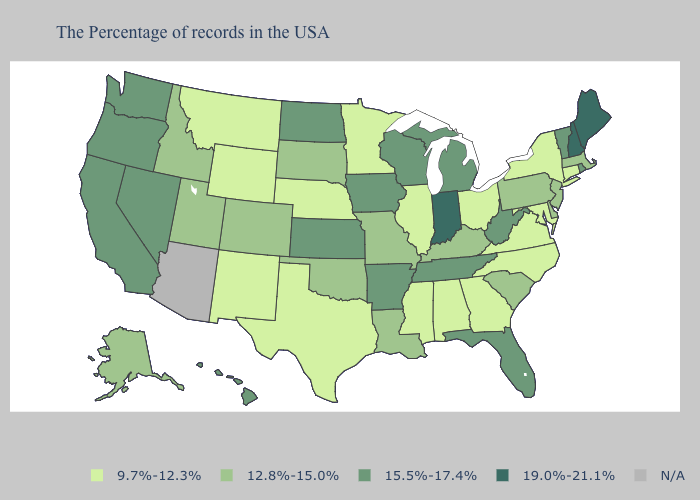Name the states that have a value in the range 9.7%-12.3%?
Quick response, please. Connecticut, New York, Maryland, Virginia, North Carolina, Ohio, Georgia, Alabama, Illinois, Mississippi, Minnesota, Nebraska, Texas, Wyoming, New Mexico, Montana. Does Illinois have the lowest value in the USA?
Keep it brief. Yes. Does the map have missing data?
Quick response, please. Yes. What is the highest value in the USA?
Give a very brief answer. 19.0%-21.1%. Which states have the lowest value in the USA?
Concise answer only. Connecticut, New York, Maryland, Virginia, North Carolina, Ohio, Georgia, Alabama, Illinois, Mississippi, Minnesota, Nebraska, Texas, Wyoming, New Mexico, Montana. What is the value of South Dakota?
Quick response, please. 12.8%-15.0%. Does Oregon have the highest value in the West?
Quick response, please. Yes. Which states have the lowest value in the MidWest?
Write a very short answer. Ohio, Illinois, Minnesota, Nebraska. What is the value of Nevada?
Keep it brief. 15.5%-17.4%. What is the lowest value in states that border New Mexico?
Concise answer only. 9.7%-12.3%. What is the value of Nevada?
Be succinct. 15.5%-17.4%. What is the value of South Dakota?
Write a very short answer. 12.8%-15.0%. Which states have the lowest value in the MidWest?
Write a very short answer. Ohio, Illinois, Minnesota, Nebraska. What is the value of South Dakota?
Keep it brief. 12.8%-15.0%. 